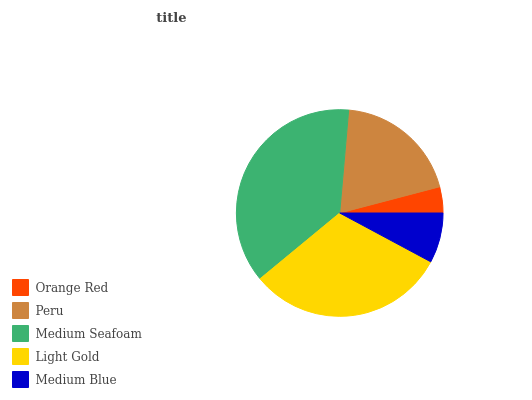Is Orange Red the minimum?
Answer yes or no. Yes. Is Medium Seafoam the maximum?
Answer yes or no. Yes. Is Peru the minimum?
Answer yes or no. No. Is Peru the maximum?
Answer yes or no. No. Is Peru greater than Orange Red?
Answer yes or no. Yes. Is Orange Red less than Peru?
Answer yes or no. Yes. Is Orange Red greater than Peru?
Answer yes or no. No. Is Peru less than Orange Red?
Answer yes or no. No. Is Peru the high median?
Answer yes or no. Yes. Is Peru the low median?
Answer yes or no. Yes. Is Medium Blue the high median?
Answer yes or no. No. Is Orange Red the low median?
Answer yes or no. No. 